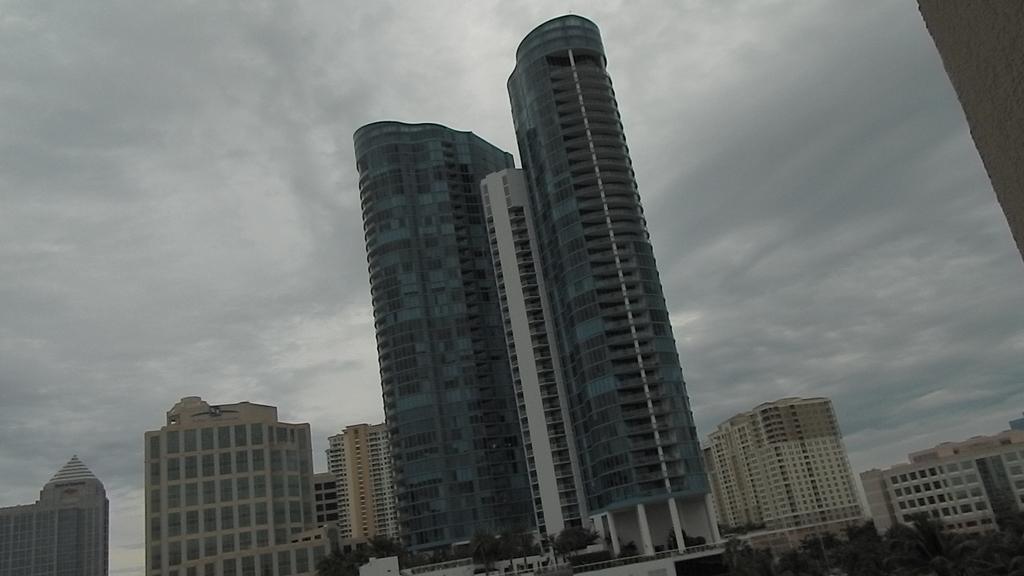Please provide a concise description of this image. In this image we can see buildings, trees at front and sky at the background. 